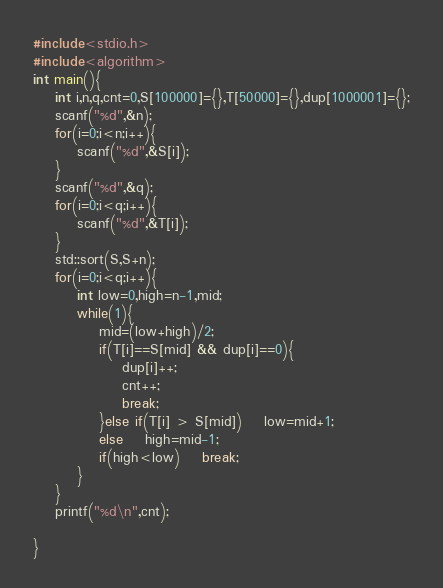Convert code to text. <code><loc_0><loc_0><loc_500><loc_500><_C++_>#include<stdio.h>
#include<algorithm>
int main(){
	int i,n,q,cnt=0,S[100000]={},T[50000]={},dup[1000001]={};
	scanf("%d",&n);
	for(i=0;i<n;i++){
		scanf("%d",&S[i]);
	}
	scanf("%d",&q);
	for(i=0;i<q;i++){
		scanf("%d",&T[i]);
	}
	std::sort(S,S+n);
	for(i=0;i<q;i++){
		int low=0,high=n-1,mid;
		while(1){
			mid=(low+high)/2;
			if(T[i]==S[mid] && dup[i]==0){
				dup[i]++;
				cnt++;
				break;
			}else if(T[i] > S[mid])	low=mid+1;
			else	high=mid-1;
			if(high<low)	break;
		}
	}
	printf("%d\n",cnt);
	
}</code> 